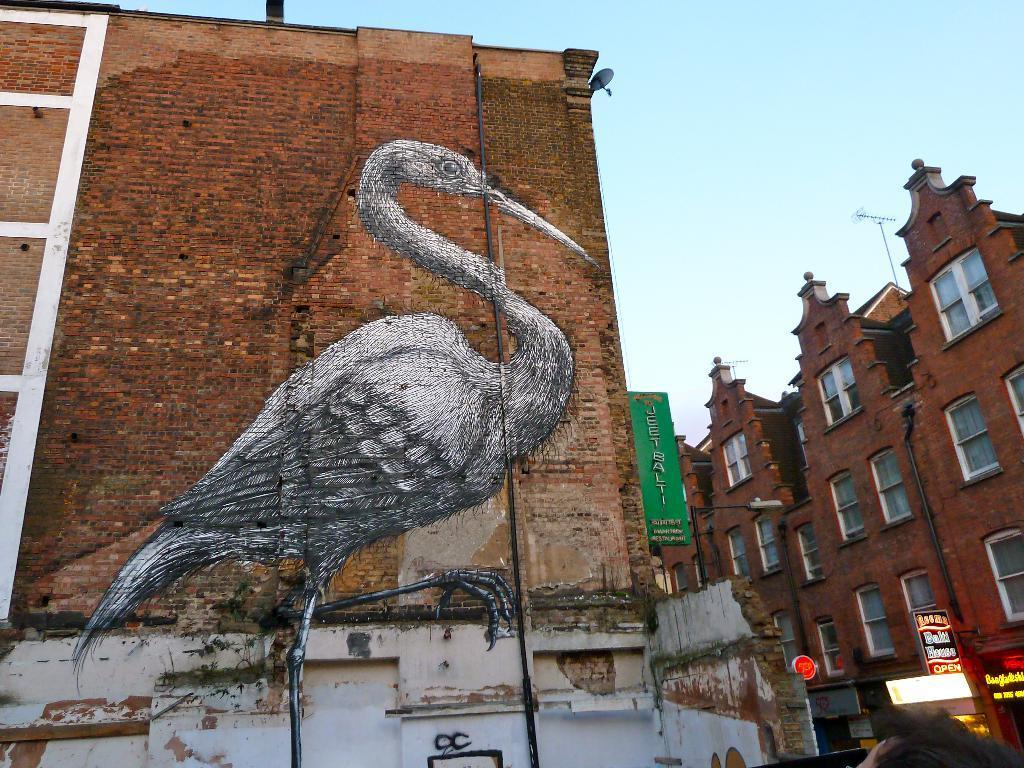Please provide a concise description of this image. In this image we can see a brick wall on which we can see an art of a bird on it. Here we can see the board, light poles, buildings and sky in the background. 